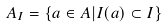Convert formula to latex. <formula><loc_0><loc_0><loc_500><loc_500>A _ { I } = \{ a \in A | I ( a ) \subset I \}</formula> 